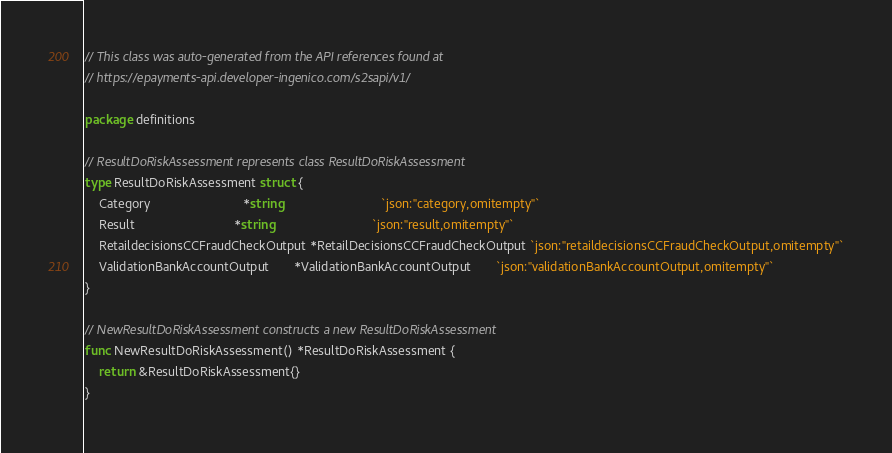<code> <loc_0><loc_0><loc_500><loc_500><_Go_>// This class was auto-generated from the API references found at
// https://epayments-api.developer-ingenico.com/s2sapi/v1/

package definitions

// ResultDoRiskAssessment represents class ResultDoRiskAssessment
type ResultDoRiskAssessment struct {
	Category                          *string                            `json:"category,omitempty"`
	Result                            *string                            `json:"result,omitempty"`
	RetaildecisionsCCFraudCheckOutput *RetailDecisionsCCFraudCheckOutput `json:"retaildecisionsCCFraudCheckOutput,omitempty"`
	ValidationBankAccountOutput       *ValidationBankAccountOutput       `json:"validationBankAccountOutput,omitempty"`
}

// NewResultDoRiskAssessment constructs a new ResultDoRiskAssessment
func NewResultDoRiskAssessment() *ResultDoRiskAssessment {
	return &ResultDoRiskAssessment{}
}
</code> 